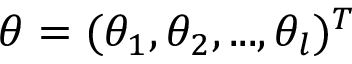<formula> <loc_0><loc_0><loc_500><loc_500>\theta = ( \theta _ { 1 } , \theta _ { 2 } , \dots , \theta _ { l } ) ^ { T }</formula> 